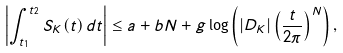Convert formula to latex. <formula><loc_0><loc_0><loc_500><loc_500>\left | \int _ { t _ { 1 } } ^ { t _ { 2 } } S _ { K } ( t ) \, d t \right | \leq a + b N + g \log \left ( | D _ { K } | \left ( \frac { t } { 2 \pi } \right ) ^ { N } \right ) ,</formula> 